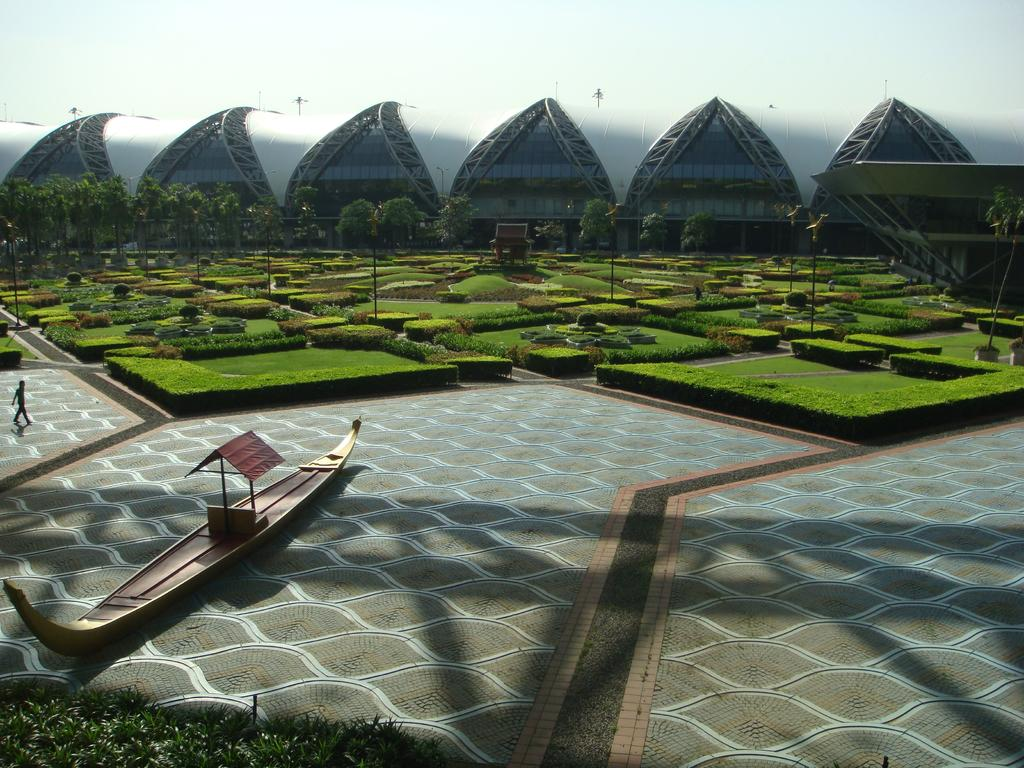What is the person in the image doing? The person is walking in the image. What can be seen on the water in the image? There is a boat on the surface of the water. What type of vegetation is visible in the image? There are plants, grass, and trees visible in the image. What structures can be seen in the image? There are poles and a building visible in the image. What is visible in the background of the image? The sky and a building are visible in the background of the image. Where can the honey be found in the image? There is no honey present in the image. What type of surface are the cows walking on in the image? There are no cows present in the image. 